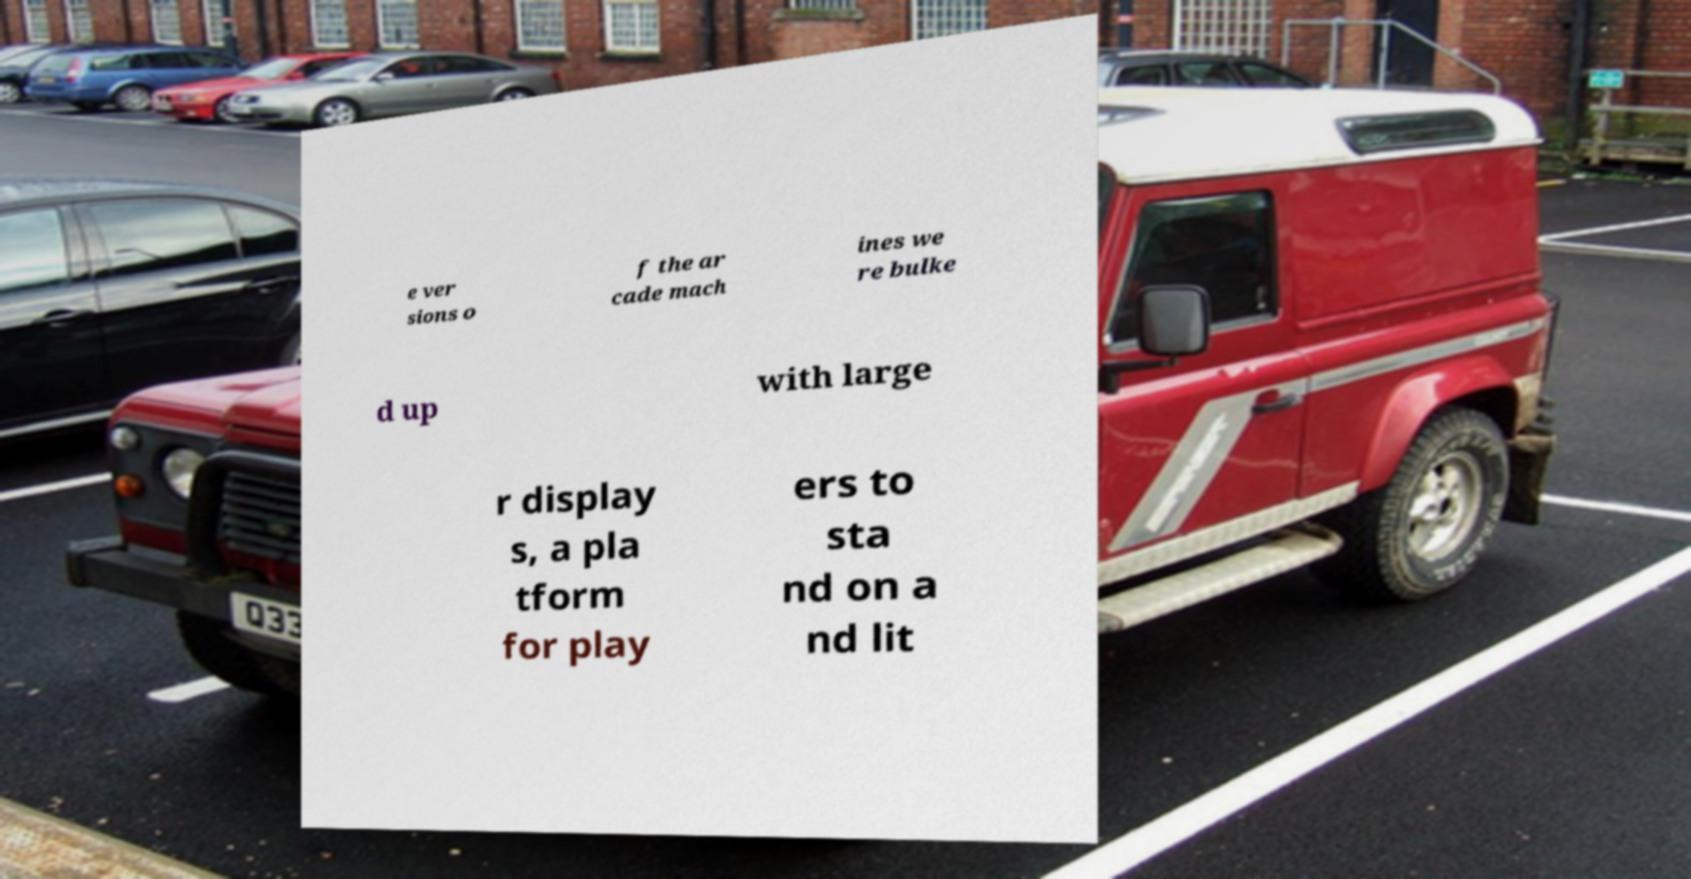For documentation purposes, I need the text within this image transcribed. Could you provide that? e ver sions o f the ar cade mach ines we re bulke d up with large r display s, a pla tform for play ers to sta nd on a nd lit 